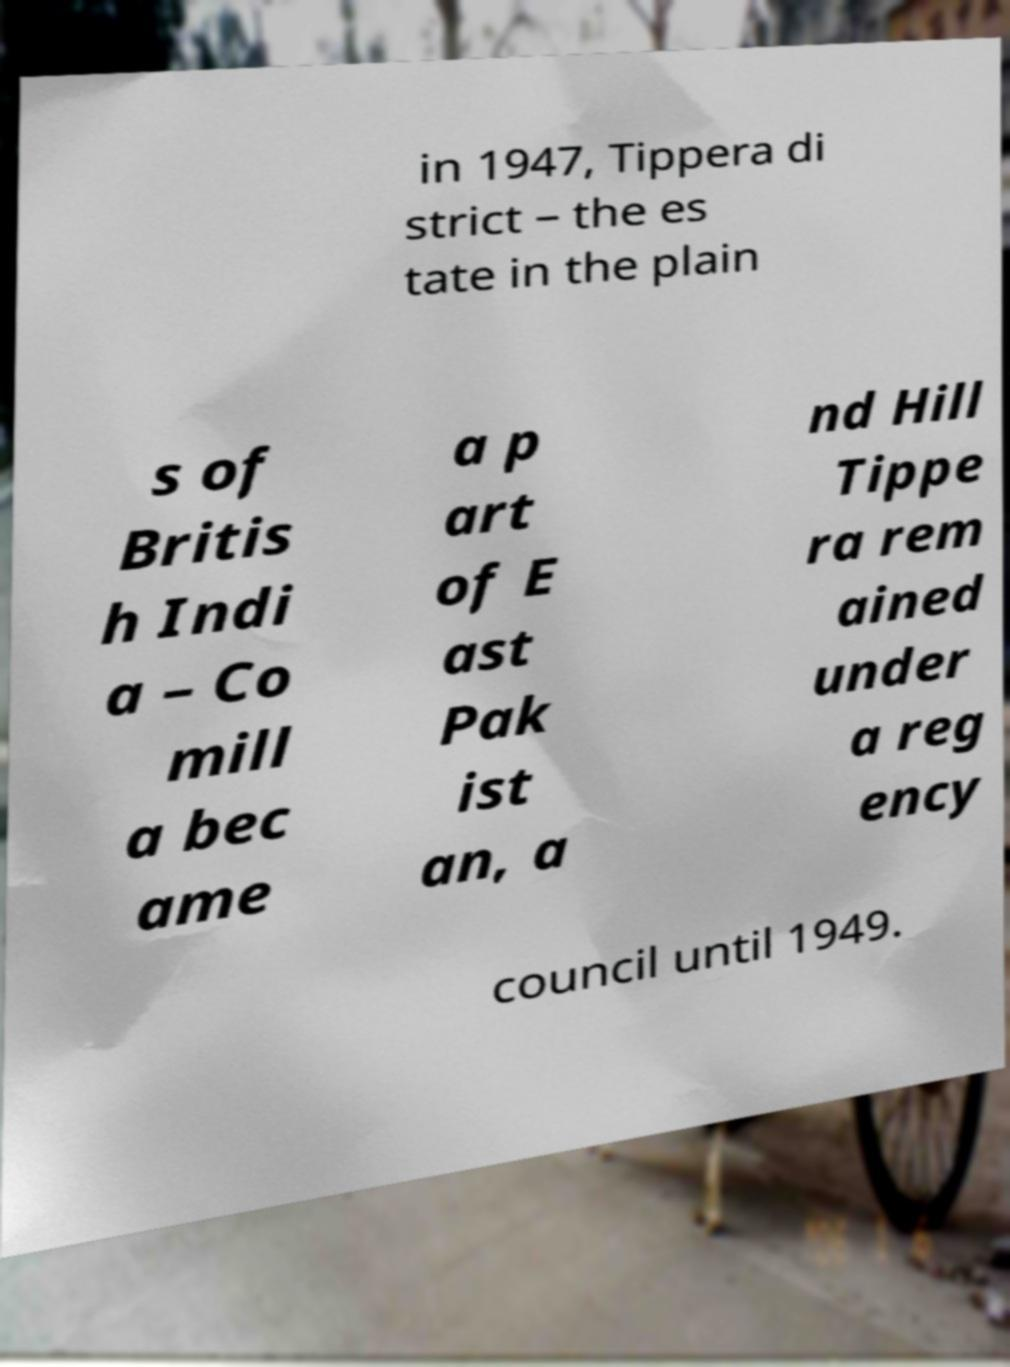Please identify and transcribe the text found in this image. in 1947, Tippera di strict – the es tate in the plain s of Britis h Indi a – Co mill a bec ame a p art of E ast Pak ist an, a nd Hill Tippe ra rem ained under a reg ency council until 1949. 